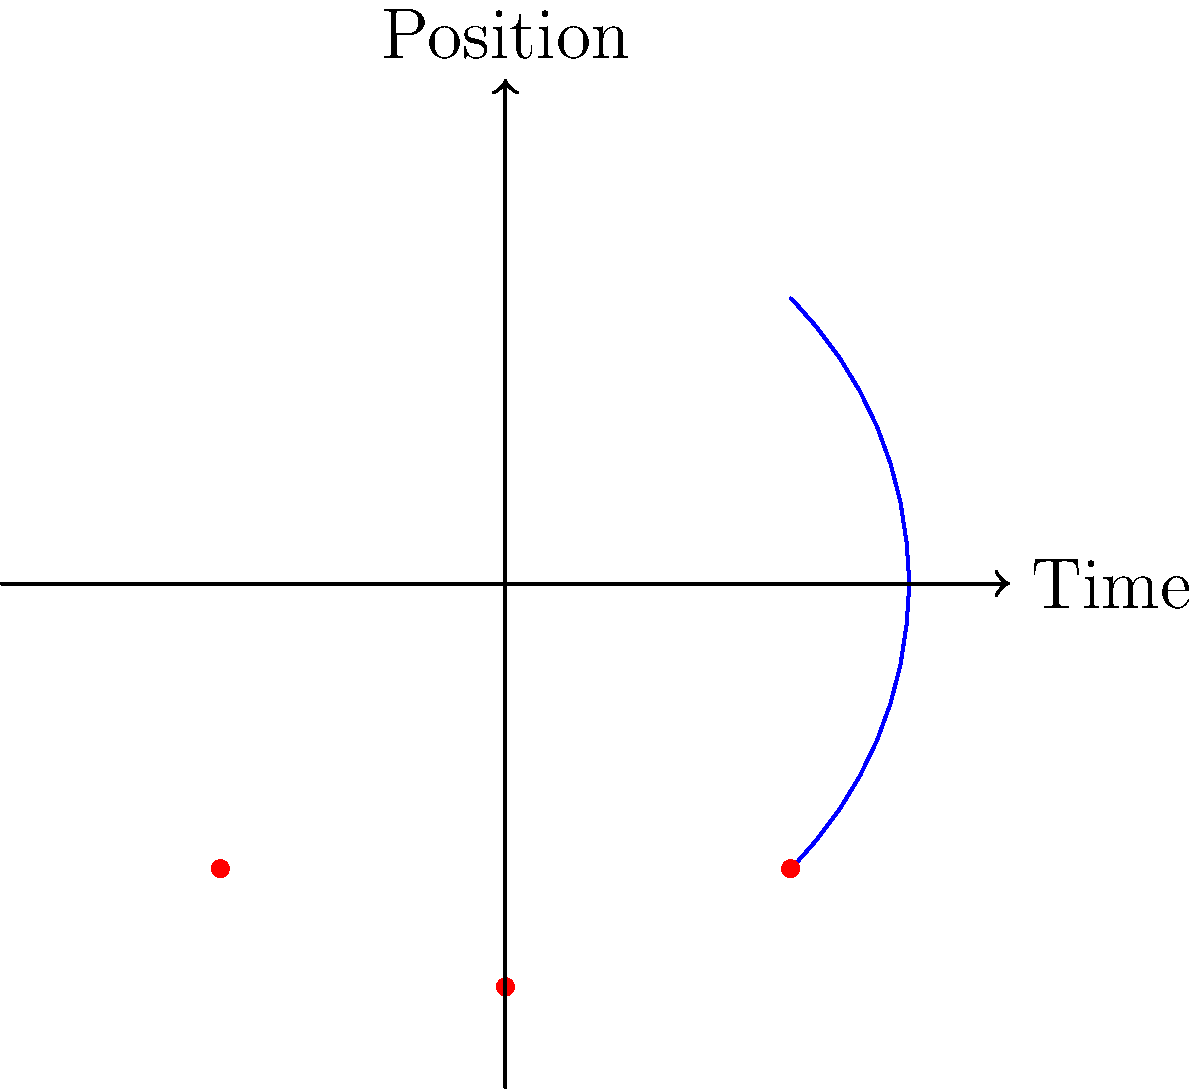In a pendulum swing animation, which principle of traditional animation is best demonstrated by varying the spacing between the pendulum's positions while maintaining consistent timing? To answer this question, let's break down the principles of animation and how they apply to a pendulum swing:

1. Timing: This refers to the number of frames or drawings used for an action. In our pendulum example, consistent timing would mean equal time intervals between each position of the pendulum.

2. Spacing: This is the distance between each successive position of an animated object. In the pendulum swing, the spacing between positions varies.

3. Slow in and slow out: This principle describes how movement tends to accelerate and decelerate rather than maintain constant speed.

4. Arcs: Natural movement tends to follow curved paths rather than straight lines.

In the given pendulum animation:
- The timing is consistent (equal time intervals between positions).
- The spacing varies: it's closer at the ends of the swing and wider in the middle.
- This varying spacing creates a slow in and slow out effect, as the pendulum naturally slows down at the ends of its swing and speeds up in the middle.
- The pendulum follows an arc path.

The principle that is best demonstrated by varying the spacing while maintaining consistent timing is "slow in and slow out." This principle gives the animation a more natural, physics-based feel, as it accurately represents the way a real pendulum would move, slowing down at the extremes of its swing and speeding up in the middle.
Answer: Slow in and slow out 